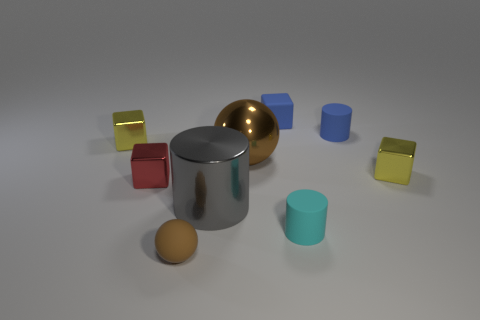Subtract all tiny blue matte blocks. How many blocks are left? 3 Subtract all yellow spheres. How many yellow blocks are left? 2 Subtract all blue blocks. How many blocks are left? 3 Subtract 0 cyan cubes. How many objects are left? 9 Subtract all spheres. How many objects are left? 7 Subtract 1 spheres. How many spheres are left? 1 Subtract all gray cylinders. Subtract all purple blocks. How many cylinders are left? 2 Subtract all blue rubber objects. Subtract all yellow shiny blocks. How many objects are left? 5 Add 4 yellow objects. How many yellow objects are left? 6 Add 8 tiny red objects. How many tiny red objects exist? 9 